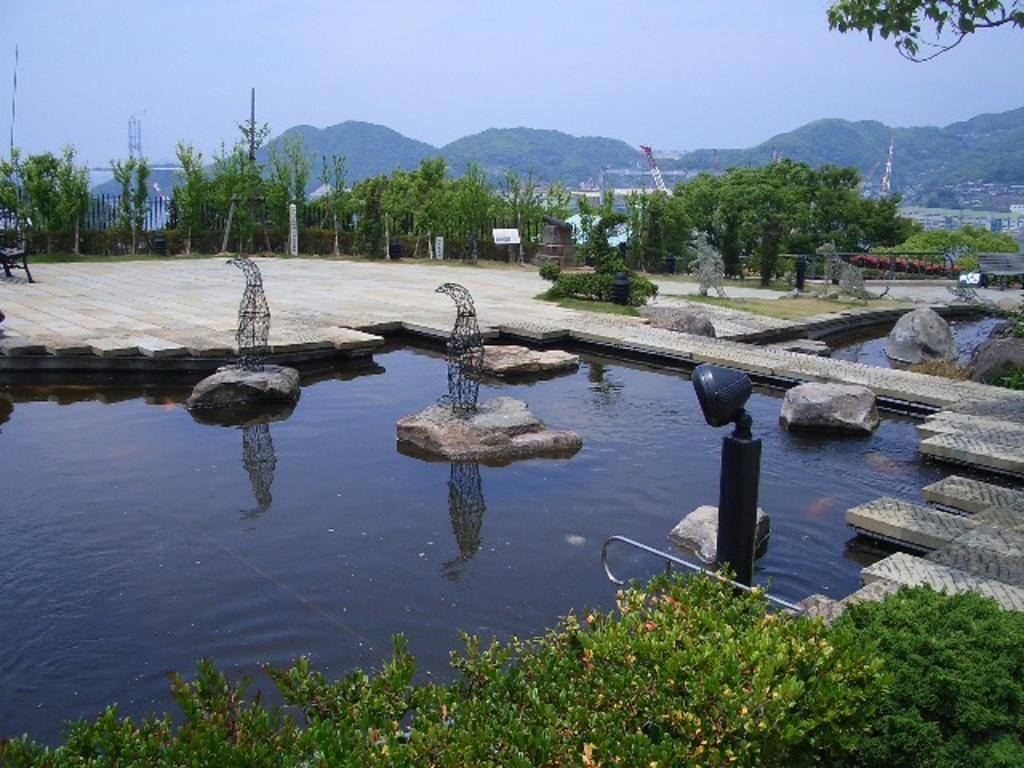What is the primary element visible in the image? There is water in the image. What can be seen within the water? There are rocks in the water. What type of natural scenery is visible in the background of the image? There are trees in the background of the image. What type of man-made structures can be seen in the background of the image? There are buildings in the background of the image. What type of wing is visible on the nation in the image? There is no nation or wing present in the image; it features water with rocks and a background of trees and buildings. 